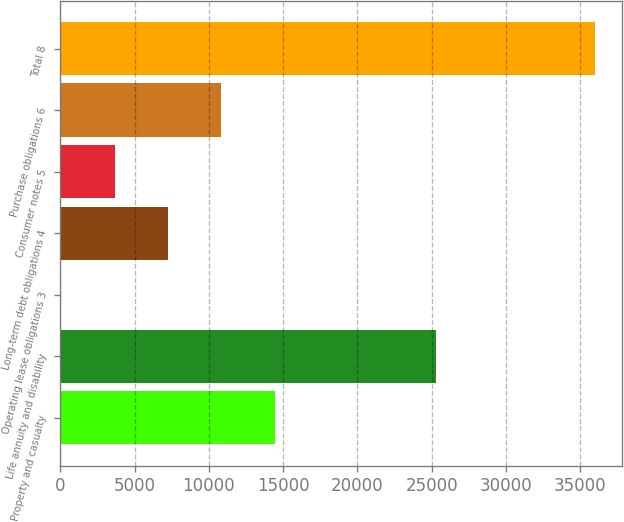Convert chart to OTSL. <chart><loc_0><loc_0><loc_500><loc_500><bar_chart><fcel>Property and casualty<fcel>Life annuity and disability<fcel>Operating lease obligations 3<fcel>Long-term debt obligations 4<fcel>Consumer notes 5<fcel>Purchase obligations 6<fcel>Total 8<nl><fcel>14431.8<fcel>25265<fcel>61<fcel>7246.4<fcel>3653.7<fcel>10839.1<fcel>35988<nl></chart> 